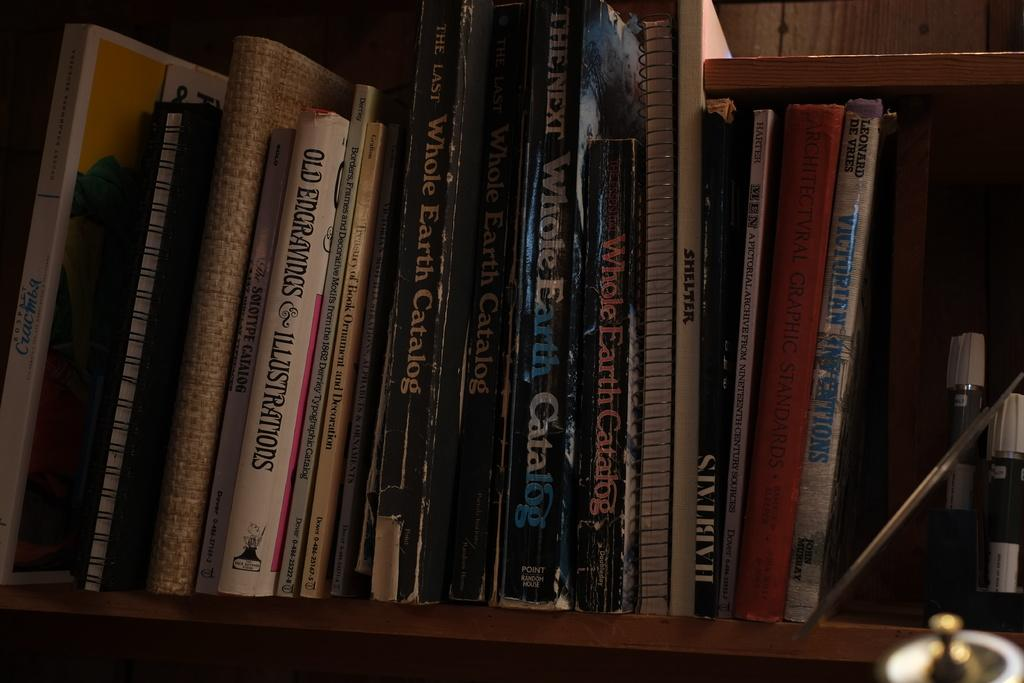<image>
Create a compact narrative representing the image presented. Various books on a wooden shelf and one of them is an earth catalog. 